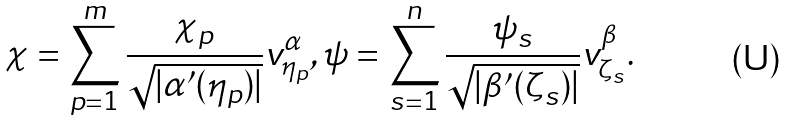<formula> <loc_0><loc_0><loc_500><loc_500>\chi = \sum _ { p = 1 } ^ { m } \frac { \chi _ { p } } { \sqrt { | \alpha ^ { \prime } ( \eta _ { p } ) | } } v _ { \eta _ { p } } ^ { \alpha } , \psi = \sum _ { s = 1 } ^ { n } \frac { \psi _ { s } } { \sqrt { | \beta ^ { \prime } ( \zeta _ { s } ) | } } v _ { \zeta _ { s } } ^ { \beta } .</formula> 